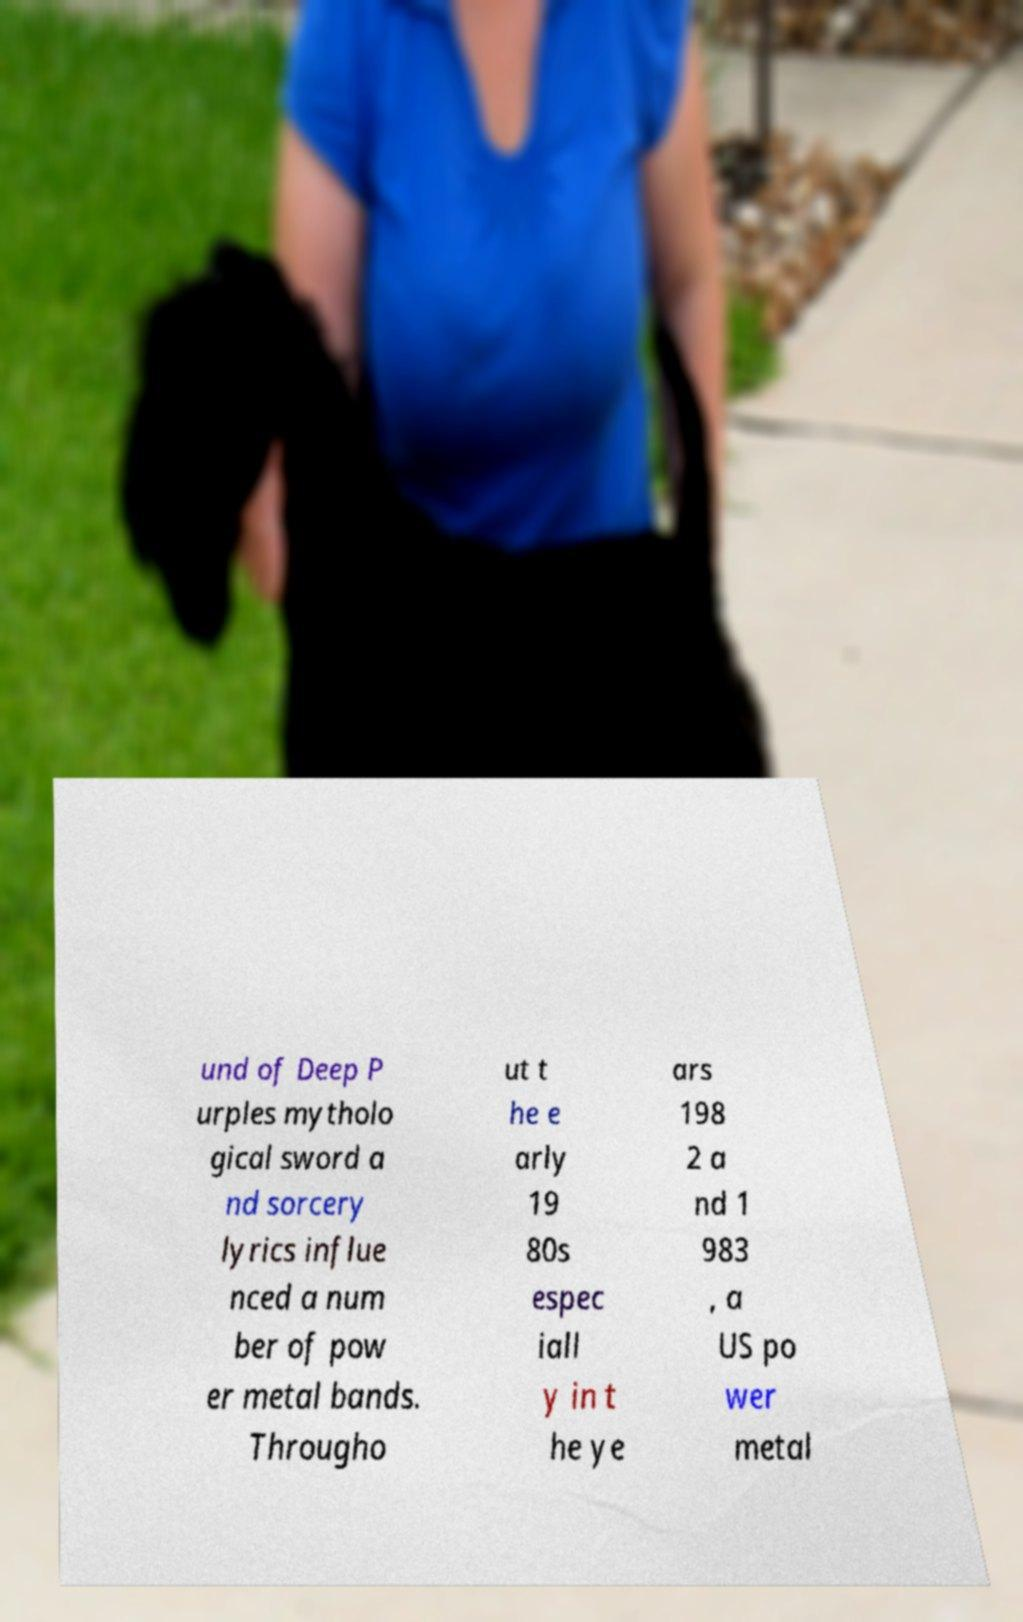Could you extract and type out the text from this image? und of Deep P urples mytholo gical sword a nd sorcery lyrics influe nced a num ber of pow er metal bands. Througho ut t he e arly 19 80s espec iall y in t he ye ars 198 2 a nd 1 983 , a US po wer metal 